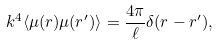Convert formula to latex. <formula><loc_0><loc_0><loc_500><loc_500>k ^ { 4 } \langle \mu ( r ) \mu ( r ^ { \prime } ) \rangle = \frac { 4 \pi } { \ell } \delta ( r - r ^ { \prime } ) ,</formula> 